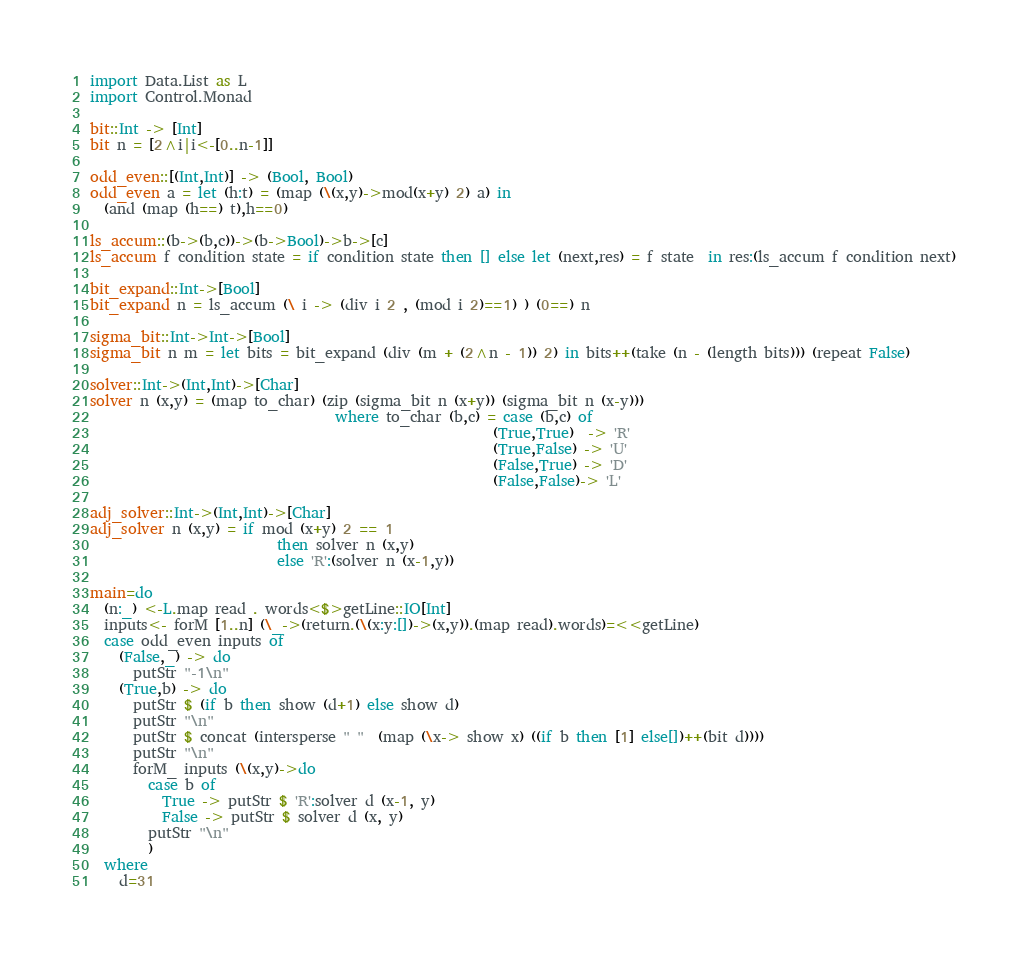Convert code to text. <code><loc_0><loc_0><loc_500><loc_500><_Haskell_>import Data.List as L
import Control.Monad

bit::Int -> [Int]
bit n = [2^i|i<-[0..n-1]]

odd_even::[(Int,Int)] -> (Bool, Bool)
odd_even a = let (h:t) = (map (\(x,y)->mod(x+y) 2) a) in
  (and (map (h==) t),h==0)

ls_accum::(b->(b,c))->(b->Bool)->b->[c]
ls_accum f condition state = if condition state then [] else let (next,res) = f state  in res:(ls_accum f condition next)

bit_expand::Int->[Bool]
bit_expand n = ls_accum (\ i -> (div i 2 , (mod i 2)==1) ) (0==) n

sigma_bit::Int->Int->[Bool]
sigma_bit n m = let bits = bit_expand (div (m + (2^n - 1)) 2) in bits++(take (n - (length bits))) (repeat False)

solver::Int->(Int,Int)->[Char]
solver n (x,y) = (map to_char) (zip (sigma_bit n (x+y)) (sigma_bit n (x-y)))
                                  where to_char (b,c) = case (b,c) of
                                                        (True,True)  -> 'R'
                                                        (True,False) -> 'U'
                                                        (False,True) -> 'D'
                                                        (False,False)-> 'L'

adj_solver::Int->(Int,Int)->[Char]
adj_solver n (x,y) = if mod (x+y) 2 == 1
                          then solver n (x,y)
                          else 'R':(solver n (x-1,y))

main=do
  (n:_) <-L.map read . words<$>getLine::IO[Int]
  inputs<- forM [1..n] (\_->(return.(\(x:y:[])->(x,y)).(map read).words)=<<getLine)
  case odd_even inputs of
    (False,_) -> do
      putStr "-1\n"
    (True,b) -> do
      putStr $ (if b then show (d+1) else show d)
      putStr "\n"
      putStr $ concat (intersperse " "  (map (\x-> show x) ((if b then [1] else[])++(bit d))))
      putStr "\n"
      forM_ inputs (\(x,y)->do
        case b of
          True -> putStr $ 'R':solver d (x-1, y)
          False -> putStr $ solver d (x, y)
        putStr "\n"
        )
  where
    d=31</code> 